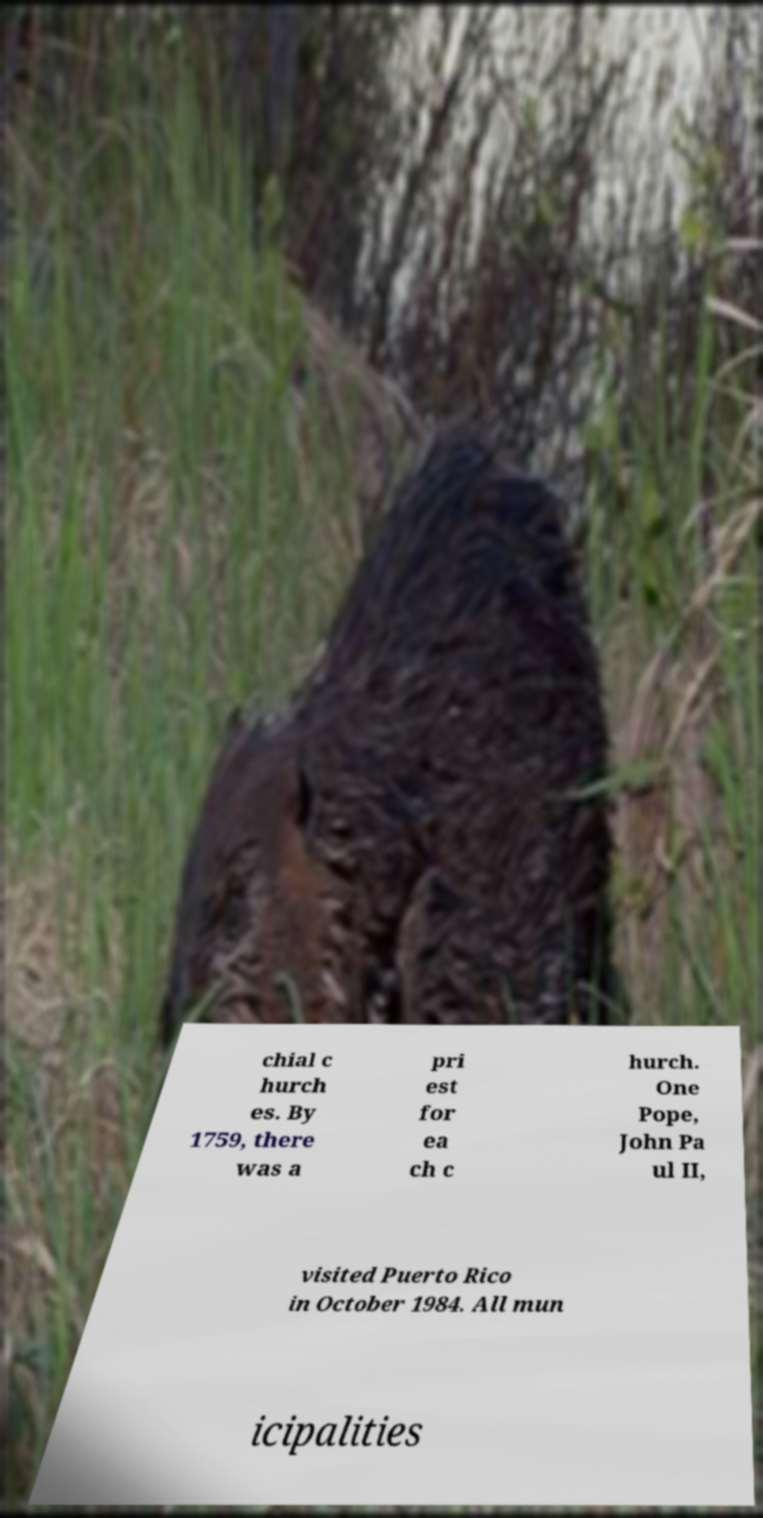What messages or text are displayed in this image? I need them in a readable, typed format. chial c hurch es. By 1759, there was a pri est for ea ch c hurch. One Pope, John Pa ul II, visited Puerto Rico in October 1984. All mun icipalities 